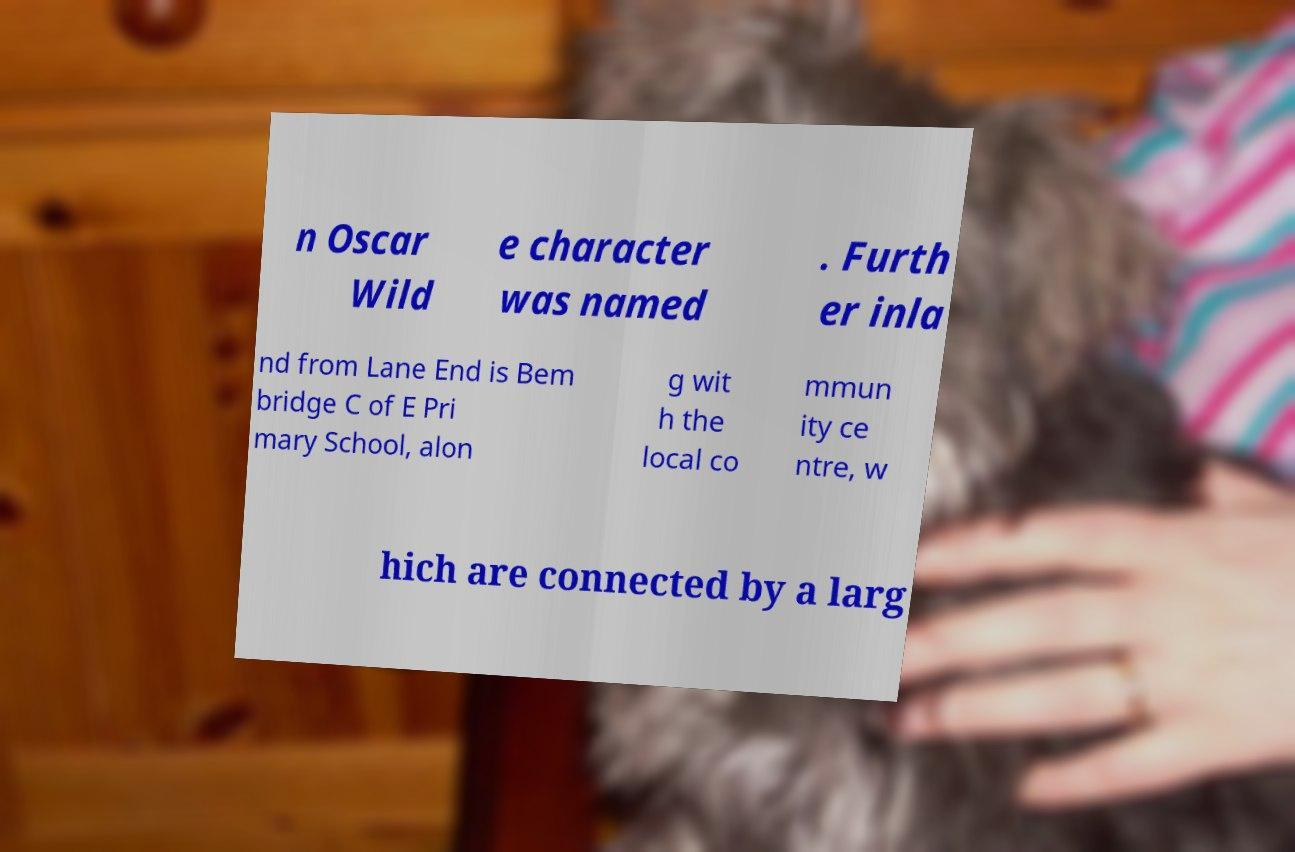Please read and relay the text visible in this image. What does it say? n Oscar Wild e character was named . Furth er inla nd from Lane End is Bem bridge C of E Pri mary School, alon g wit h the local co mmun ity ce ntre, w hich are connected by a larg 